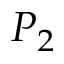Convert formula to latex. <formula><loc_0><loc_0><loc_500><loc_500>P _ { 2 }</formula> 